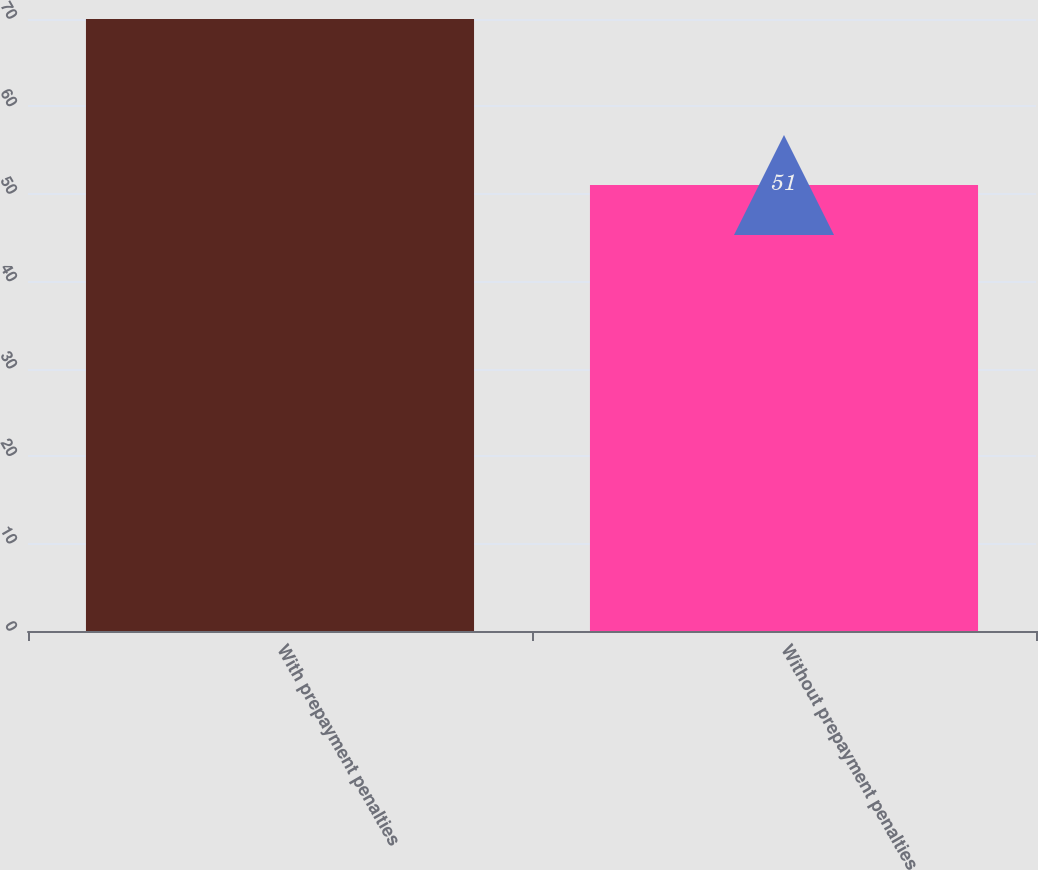Convert chart. <chart><loc_0><loc_0><loc_500><loc_500><bar_chart><fcel>With prepayment penalties<fcel>Without prepayment penalties<nl><fcel>70<fcel>51<nl></chart> 